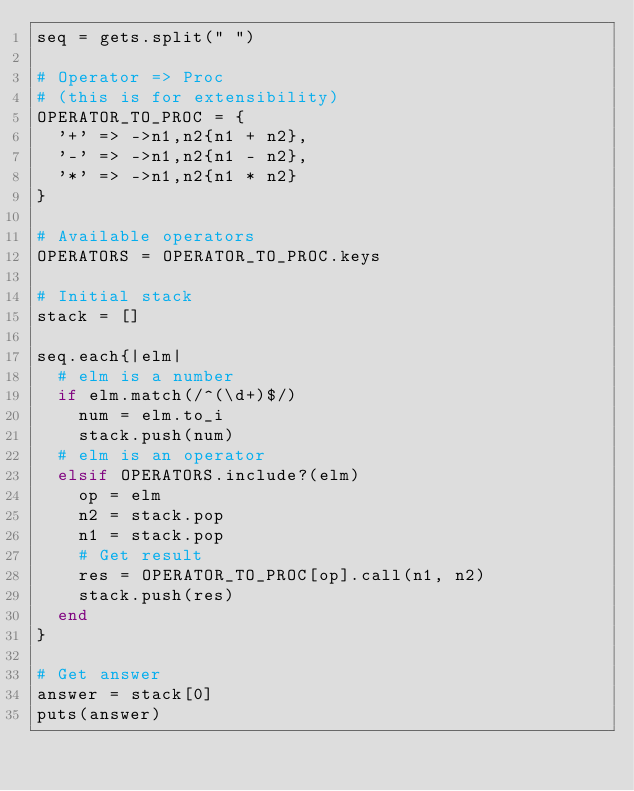<code> <loc_0><loc_0><loc_500><loc_500><_Ruby_>seq = gets.split(" ")

# Operator => Proc
# (this is for extensibility)
OPERATOR_TO_PROC = {
  '+' => ->n1,n2{n1 + n2},
  '-' => ->n1,n2{n1 - n2},
  '*' => ->n1,n2{n1 * n2}
}

# Available operators
OPERATORS = OPERATOR_TO_PROC.keys

# Initial stack
stack = []

seq.each{|elm|
  # elm is a number
  if elm.match(/^(\d+)$/)
    num = elm.to_i
    stack.push(num)
  # elm is an operator
  elsif OPERATORS.include?(elm)
    op = elm
    n2 = stack.pop
    n1 = stack.pop
    # Get result
    res = OPERATOR_TO_PROC[op].call(n1, n2)
    stack.push(res)
  end
}

# Get answer
answer = stack[0]
puts(answer)

</code> 